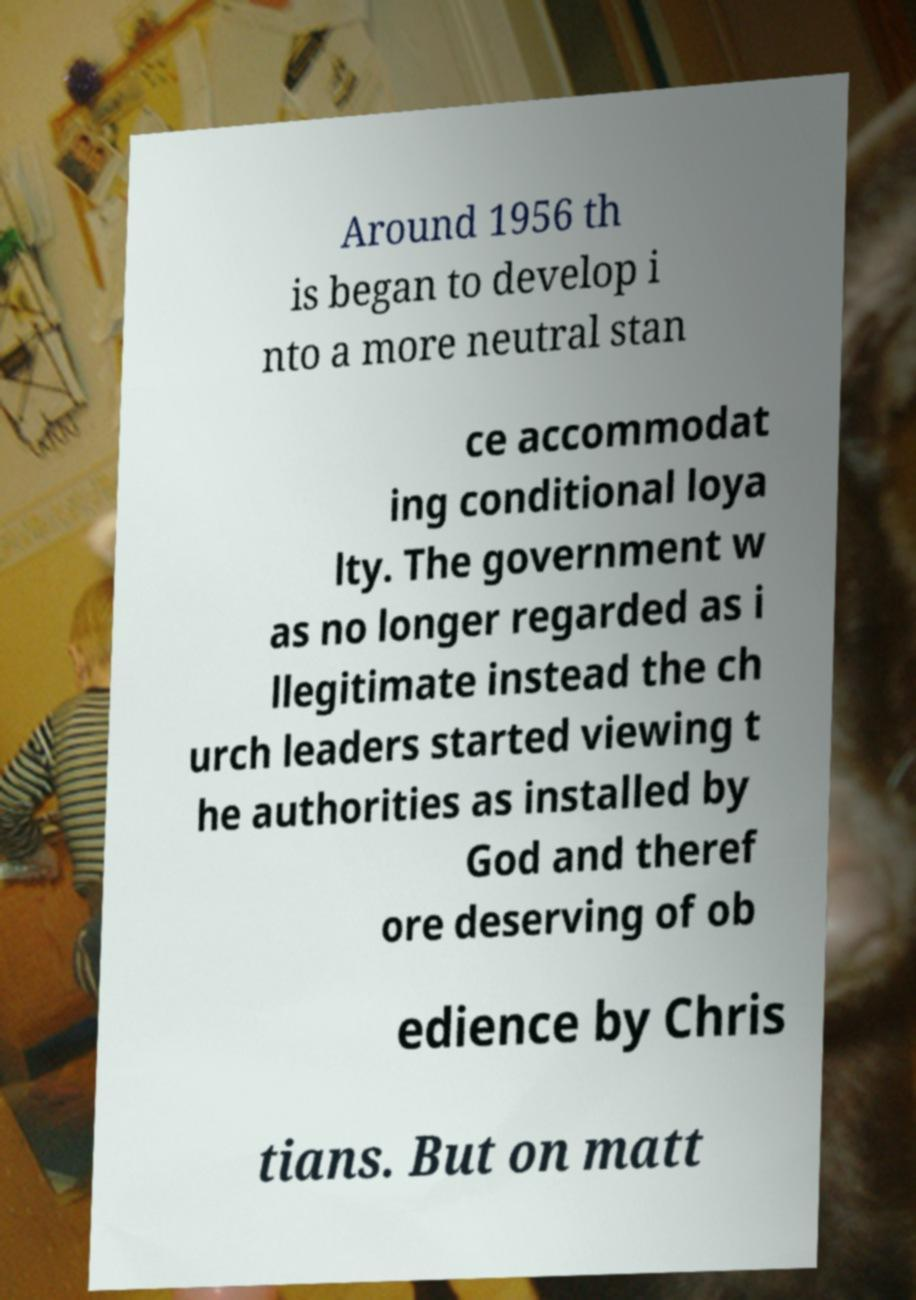Could you assist in decoding the text presented in this image and type it out clearly? Around 1956 th is began to develop i nto a more neutral stan ce accommodat ing conditional loya lty. The government w as no longer regarded as i llegitimate instead the ch urch leaders started viewing t he authorities as installed by God and theref ore deserving of ob edience by Chris tians. But on matt 